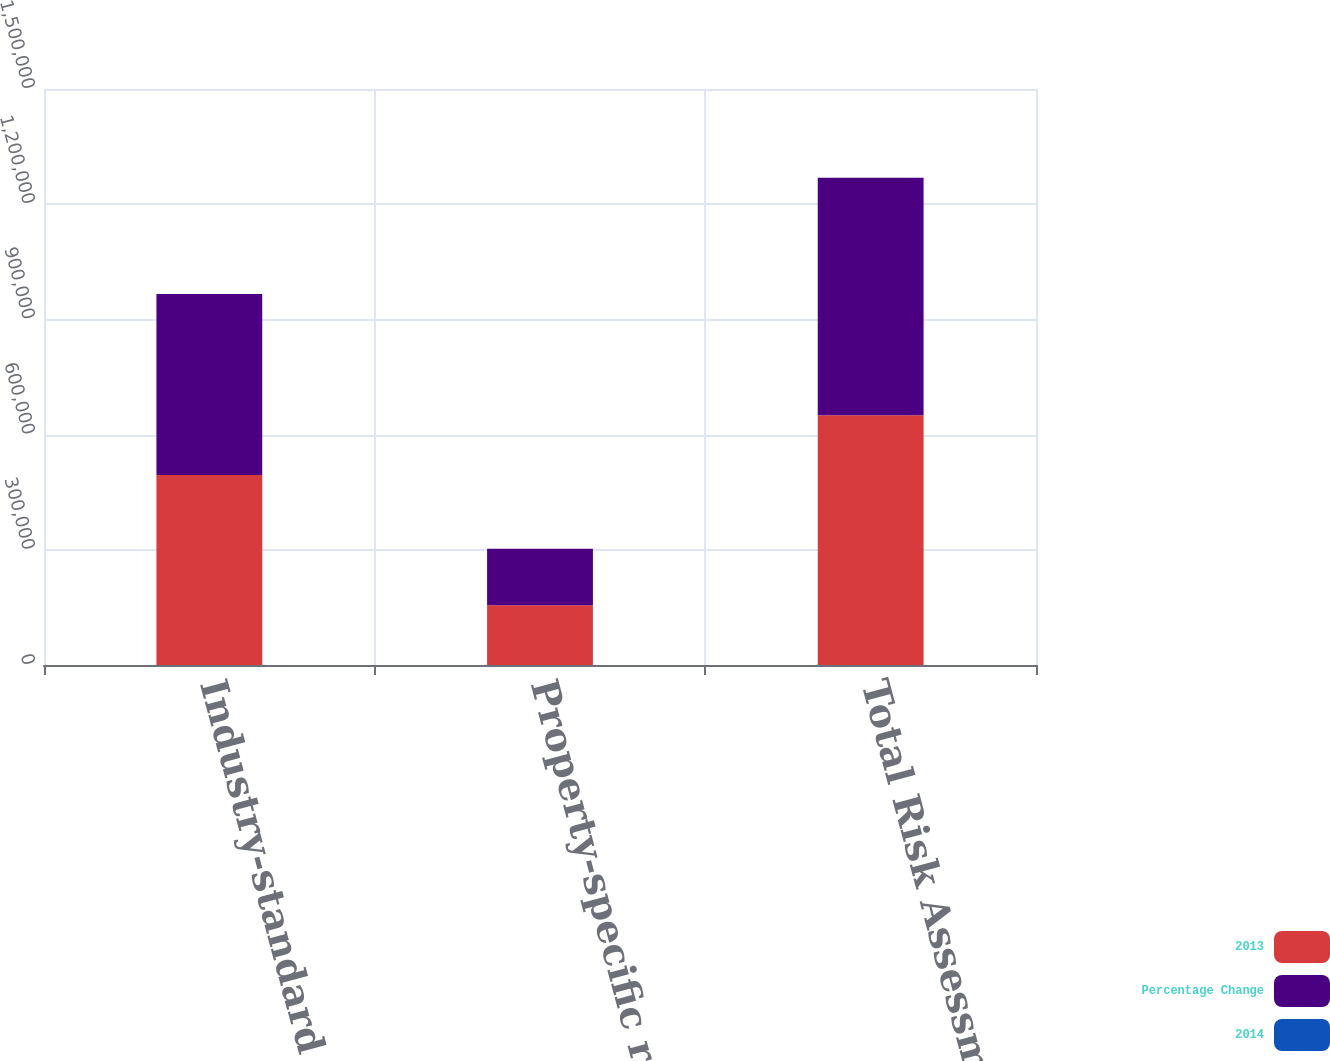<chart> <loc_0><loc_0><loc_500><loc_500><stacked_bar_chart><ecel><fcel>Industry-standard insurance<fcel>Property-specific rating and<fcel>Total Risk Assessment<nl><fcel>2013<fcel>495065<fcel>155587<fcel>650652<nl><fcel>Percentage Change<fcel>471130<fcel>147146<fcel>618276<nl><fcel>2014<fcel>5.1<fcel>5.7<fcel>5.2<nl></chart> 